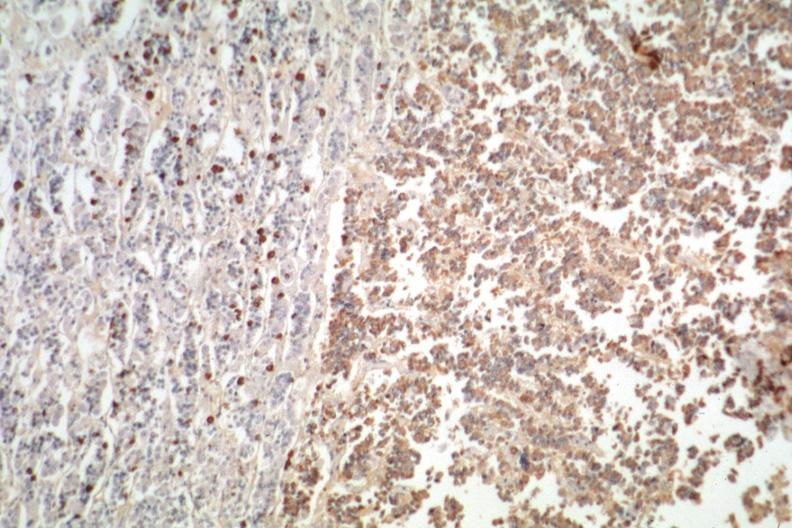s pituitary present?
Answer the question using a single word or phrase. Yes 